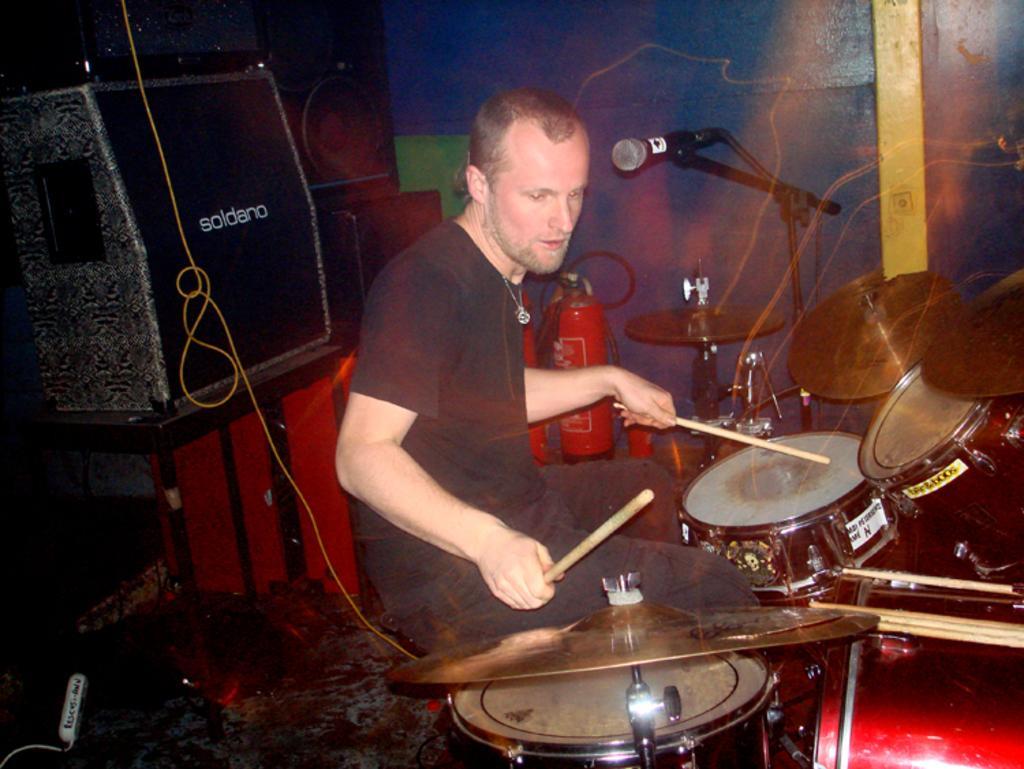Please provide a concise description of this image. In this picture we can see a man sitting, holding sticks with his hands and in front of him we can see musical instruments, mic and in the background we can see speakers, fire extinguisher, cable and some objects. 